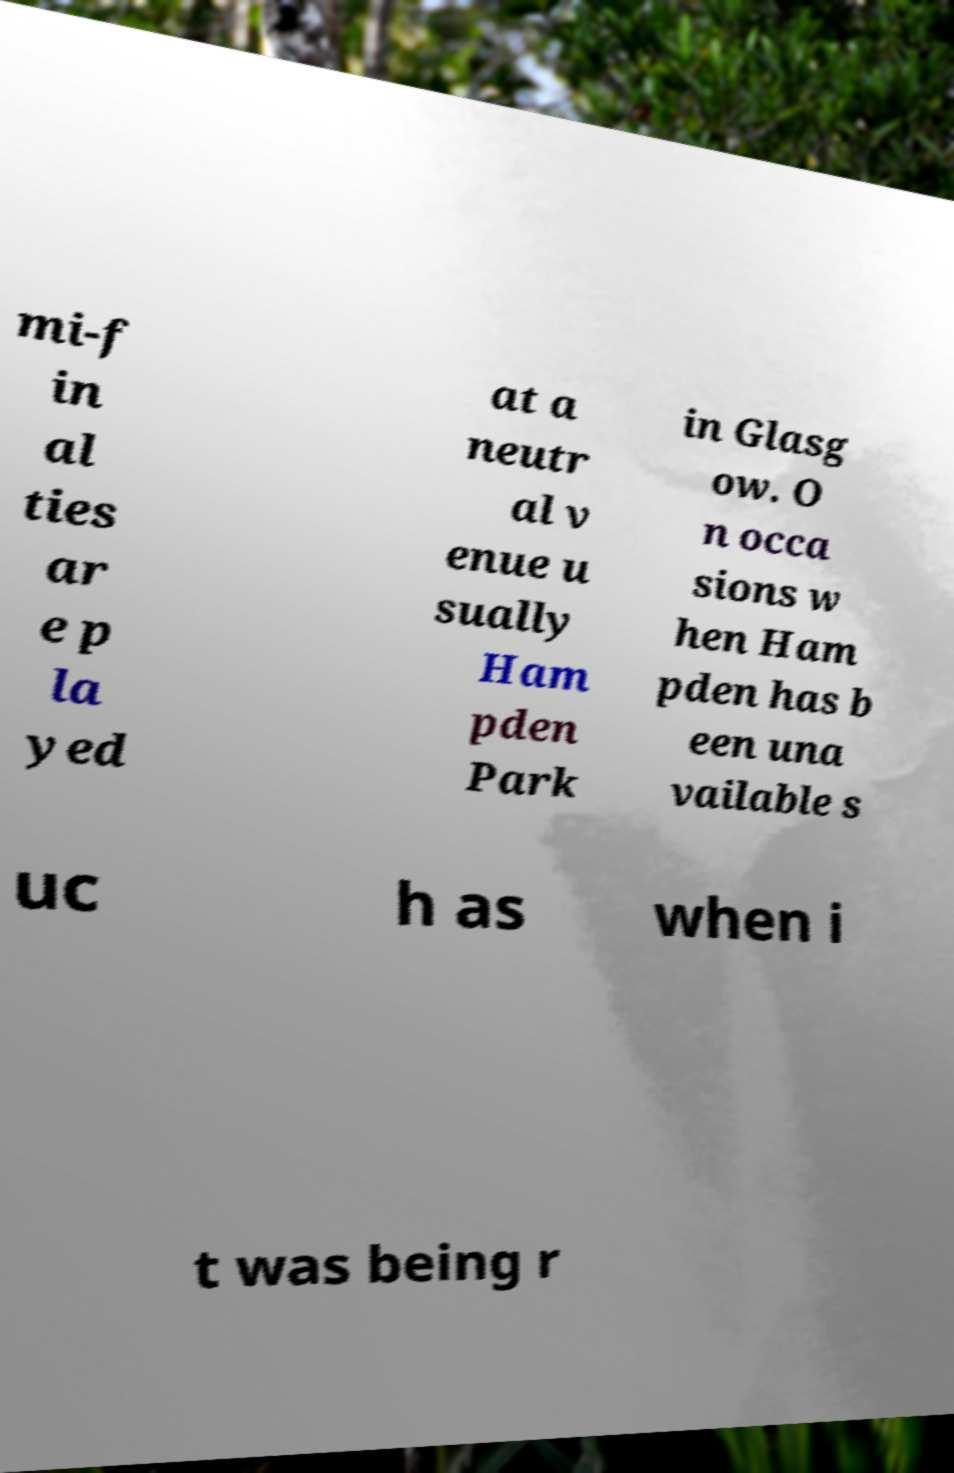I need the written content from this picture converted into text. Can you do that? mi-f in al ties ar e p la yed at a neutr al v enue u sually Ham pden Park in Glasg ow. O n occa sions w hen Ham pden has b een una vailable s uc h as when i t was being r 